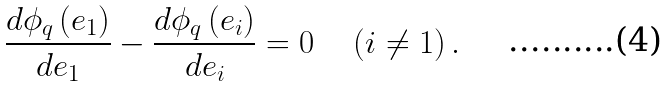<formula> <loc_0><loc_0><loc_500><loc_500>\frac { d \phi _ { q } \left ( e _ { 1 } \right ) } { d e _ { 1 } } - \frac { d \phi _ { q } \left ( e _ { i } \right ) } { d e _ { i } } = 0 \quad \left ( i \neq 1 \right ) .</formula> 